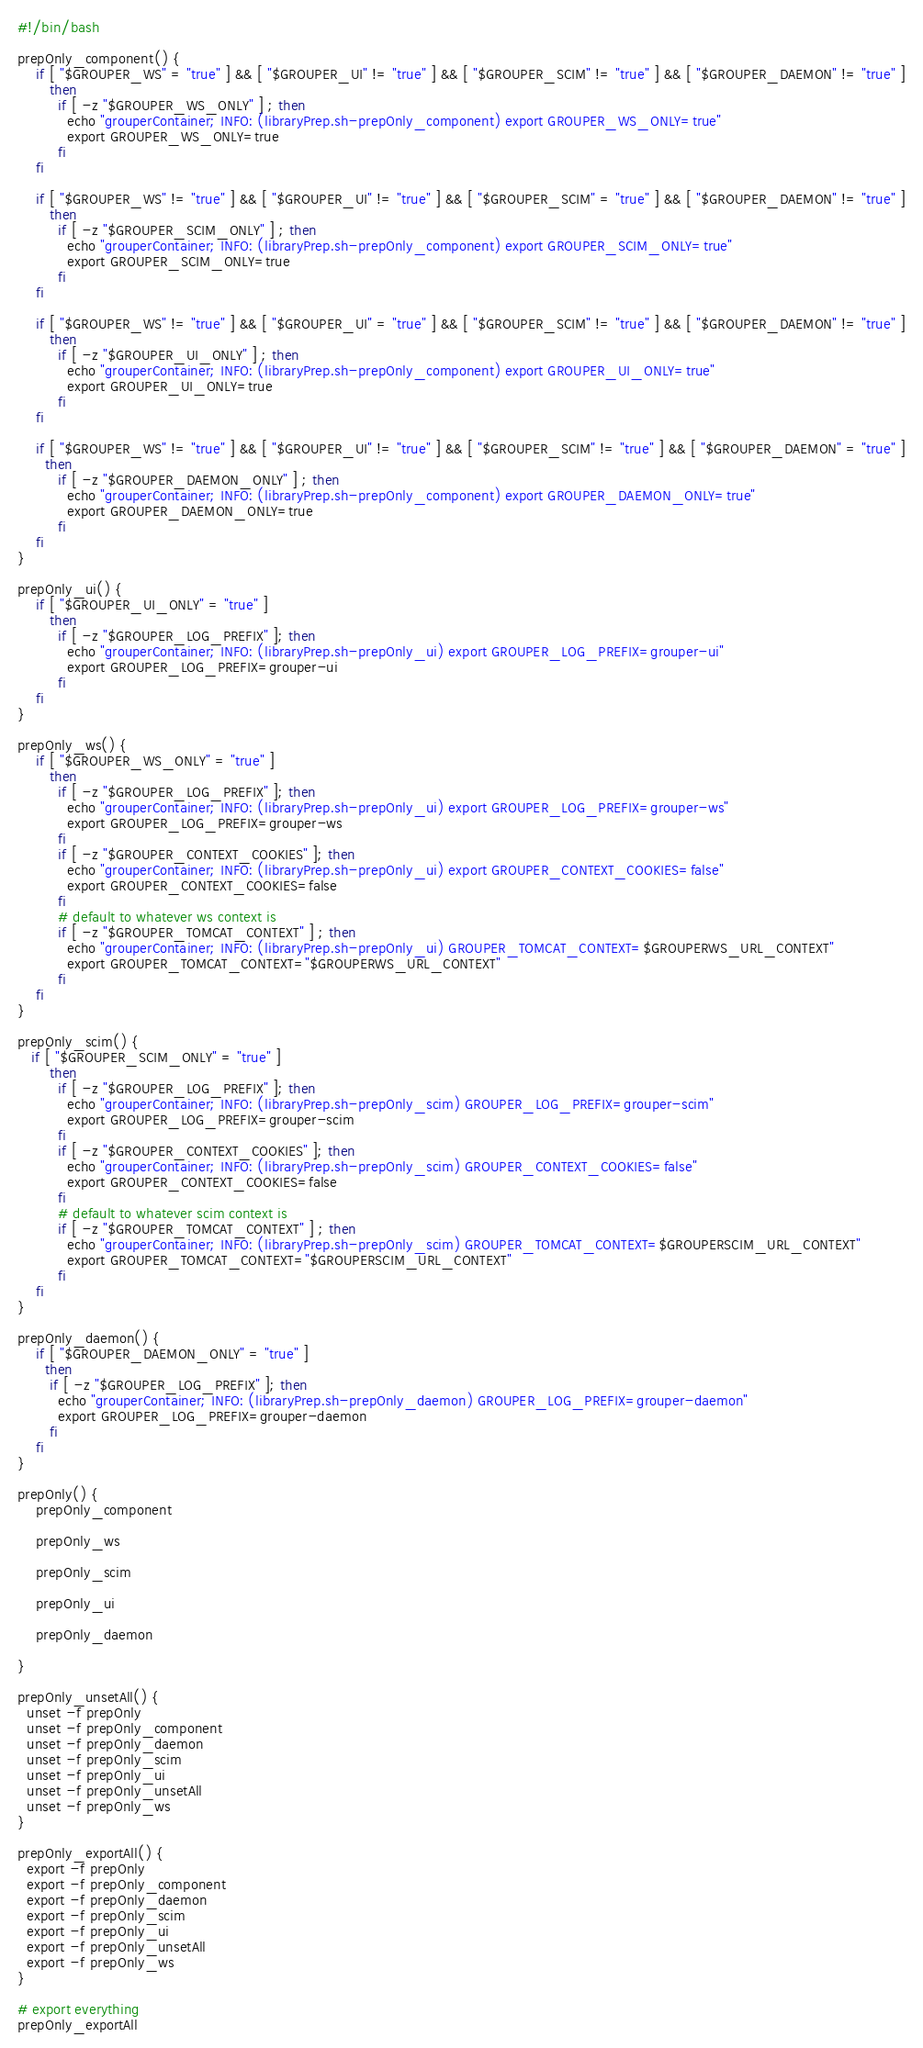<code> <loc_0><loc_0><loc_500><loc_500><_Bash_>#!/bin/bash

prepOnly_component() {
    if [ "$GROUPER_WS" = "true" ] && [ "$GROUPER_UI" != "true" ] && [ "$GROUPER_SCIM" != "true" ] && [ "$GROUPER_DAEMON" != "true" ]
       then
         if [ -z "$GROUPER_WS_ONLY" ] ; then 
           echo "grouperContainer; INFO: (libraryPrep.sh-prepOnly_component) export GROUPER_WS_ONLY=true"
           export GROUPER_WS_ONLY=true
         fi
    fi

    if [ "$GROUPER_WS" != "true" ] && [ "$GROUPER_UI" != "true" ] && [ "$GROUPER_SCIM" = "true" ] && [ "$GROUPER_DAEMON" != "true" ]
       then
         if [ -z "$GROUPER_SCIM_ONLY" ] ; then 
           echo "grouperContainer; INFO: (libraryPrep.sh-prepOnly_component) export GROUPER_SCIM_ONLY=true"
           export GROUPER_SCIM_ONLY=true
         fi
    fi

    if [ "$GROUPER_WS" != "true" ] && [ "$GROUPER_UI" = "true" ] && [ "$GROUPER_SCIM" != "true" ] && [ "$GROUPER_DAEMON" != "true" ]
       then
         if [ -z "$GROUPER_UI_ONLY" ] ; then 
           echo "grouperContainer; INFO: (libraryPrep.sh-prepOnly_component) export GROUPER_UI_ONLY=true"
           export GROUPER_UI_ONLY=true
         fi
    fi
              
    if [ "$GROUPER_WS" != "true" ] && [ "$GROUPER_UI" != "true" ] && [ "$GROUPER_SCIM" != "true" ] && [ "$GROUPER_DAEMON" = "true" ]
      then
         if [ -z "$GROUPER_DAEMON_ONLY" ] ; then 
           echo "grouperContainer; INFO: (libraryPrep.sh-prepOnly_component) export GROUPER_DAEMON_ONLY=true"
           export GROUPER_DAEMON_ONLY=true
         fi
    fi 
}

prepOnly_ui() {
    if [ "$GROUPER_UI_ONLY" = "true" ]
       then
         if [ -z "$GROUPER_LOG_PREFIX" ]; then 
           echo "grouperContainer; INFO: (libraryPrep.sh-prepOnly_ui) export GROUPER_LOG_PREFIX=grouper-ui"
           export GROUPER_LOG_PREFIX=grouper-ui
         fi
    fi
}

prepOnly_ws() {
    if [ "$GROUPER_WS_ONLY" = "true" ]
       then
         if [ -z "$GROUPER_LOG_PREFIX" ]; then  
           echo "grouperContainer; INFO: (libraryPrep.sh-prepOnly_ui) export GROUPER_LOG_PREFIX=grouper-ws"
           export GROUPER_LOG_PREFIX=grouper-ws
         fi
         if [ -z "$GROUPER_CONTEXT_COOKIES" ]; then 
           echo "grouperContainer; INFO: (libraryPrep.sh-prepOnly_ui) export GROUPER_CONTEXT_COOKIES=false"
           export GROUPER_CONTEXT_COOKIES=false
         fi
         # default to whatever ws context is
         if [ -z "$GROUPER_TOMCAT_CONTEXT" ] ; then 
           echo "grouperContainer; INFO: (libraryPrep.sh-prepOnly_ui) GROUPER_TOMCAT_CONTEXT=$GROUPERWS_URL_CONTEXT"
           export GROUPER_TOMCAT_CONTEXT="$GROUPERWS_URL_CONTEXT"
         fi
    fi
}

prepOnly_scim() {
   if [ "$GROUPER_SCIM_ONLY" = "true" ]
       then
         if [ -z "$GROUPER_LOG_PREFIX" ]; then 
           echo "grouperContainer; INFO: (libraryPrep.sh-prepOnly_scim) GROUPER_LOG_PREFIX=grouper-scim"
           export GROUPER_LOG_PREFIX=grouper-scim
         fi
         if [ -z "$GROUPER_CONTEXT_COOKIES" ]; then 
           echo "grouperContainer; INFO: (libraryPrep.sh-prepOnly_scim) GROUPER_CONTEXT_COOKIES=false"
           export GROUPER_CONTEXT_COOKIES=false
         fi
         # default to whatever scim context is
         if [ -z "$GROUPER_TOMCAT_CONTEXT" ] ; then 
           echo "grouperContainer; INFO: (libraryPrep.sh-prepOnly_scim) GROUPER_TOMCAT_CONTEXT=$GROUPERSCIM_URL_CONTEXT"
           export GROUPER_TOMCAT_CONTEXT="$GROUPERSCIM_URL_CONTEXT"
         fi
    fi
}

prepOnly_daemon() {
    if [ "$GROUPER_DAEMON_ONLY" = "true" ]
      then
       if [ -z "$GROUPER_LOG_PREFIX" ]; then
         echo "grouperContainer; INFO: (libraryPrep.sh-prepOnly_daemon) GROUPER_LOG_PREFIX=grouper-daemon"
         export GROUPER_LOG_PREFIX=grouper-daemon
       fi
    fi 
}

prepOnly() {
    prepOnly_component
    
    prepOnly_ws

    prepOnly_scim

    prepOnly_ui
              
    prepOnly_daemon

}

prepOnly_unsetAll() {
  unset -f prepOnly
  unset -f prepOnly_component
  unset -f prepOnly_daemon
  unset -f prepOnly_scim
  unset -f prepOnly_ui
  unset -f prepOnly_unsetAll
  unset -f prepOnly_ws
}

prepOnly_exportAll() {
  export -f prepOnly
  export -f prepOnly_component
  export -f prepOnly_daemon
  export -f prepOnly_scim
  export -f prepOnly_ui
  export -f prepOnly_unsetAll
  export -f prepOnly_ws
}

# export everything
prepOnly_exportAll</code> 